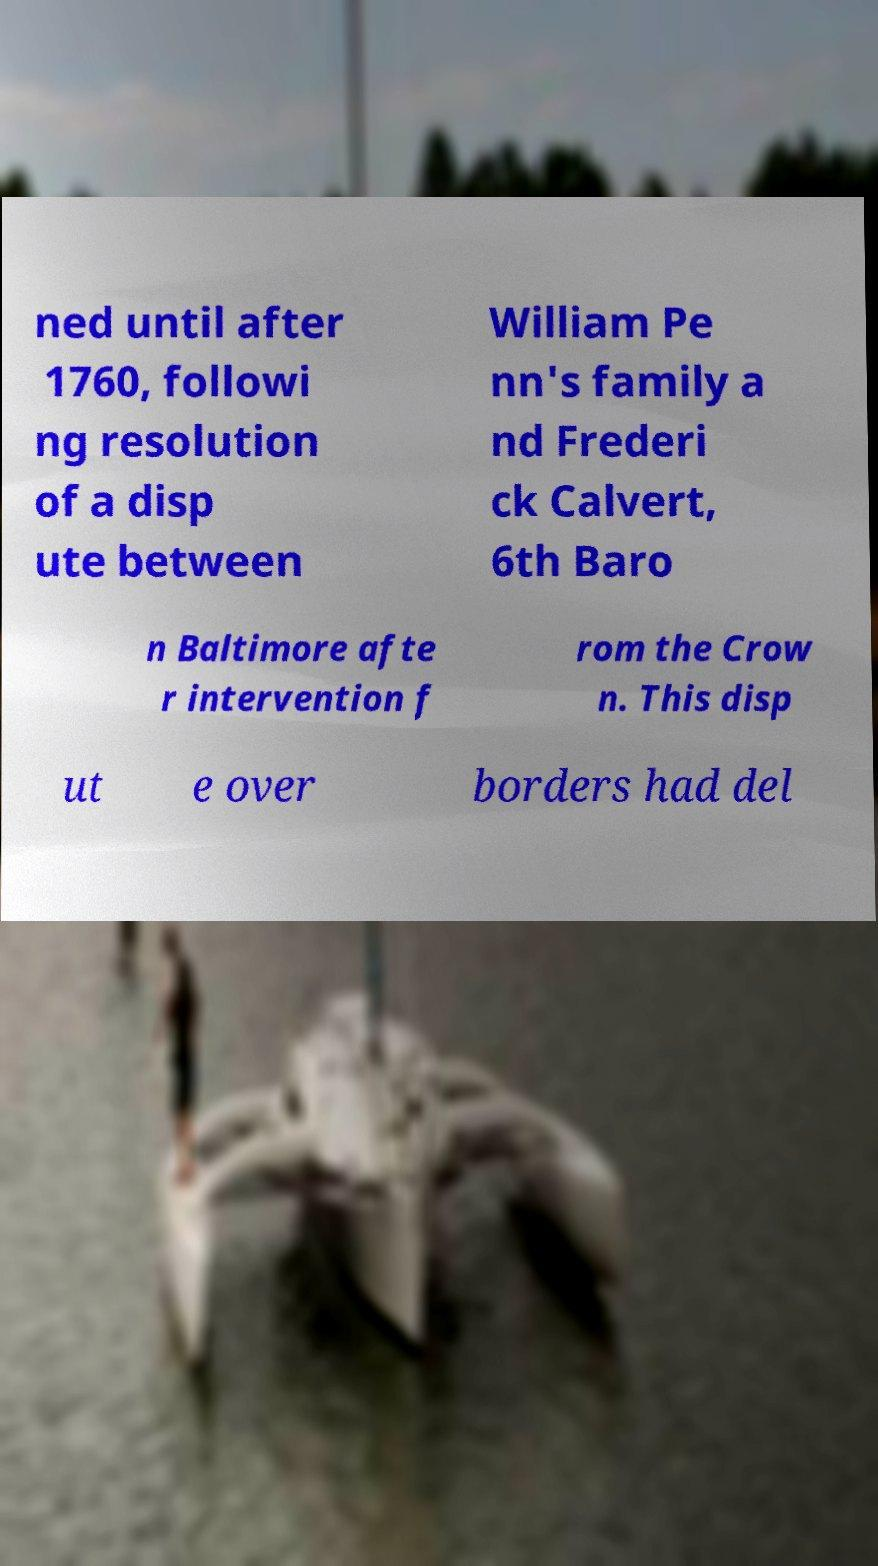Could you assist in decoding the text presented in this image and type it out clearly? ned until after 1760, followi ng resolution of a disp ute between William Pe nn's family a nd Frederi ck Calvert, 6th Baro n Baltimore afte r intervention f rom the Crow n. This disp ut e over borders had del 